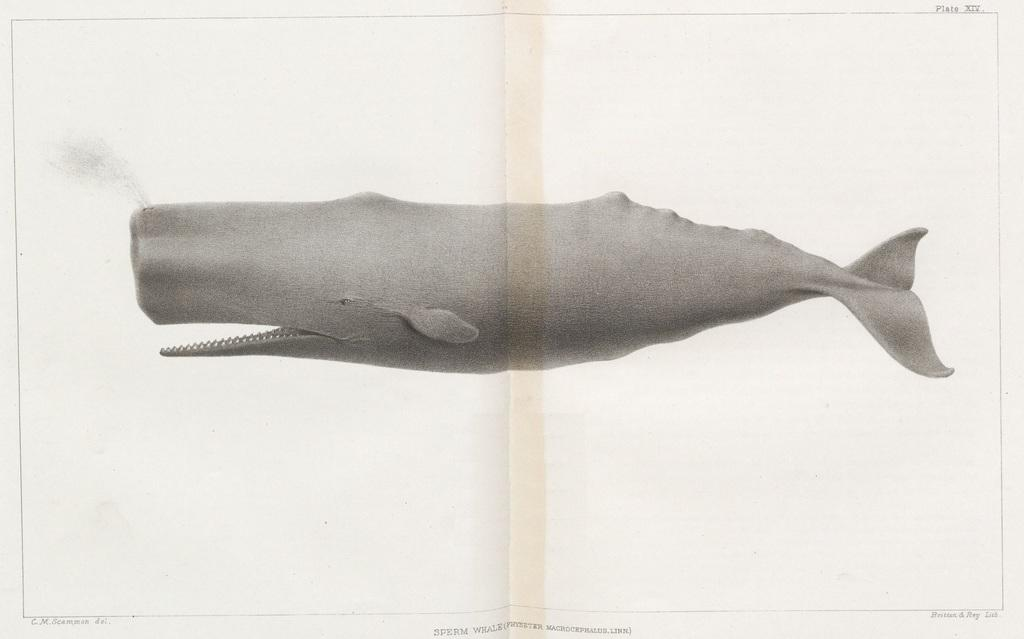What is the color scheme of the image? The image is black and white. What is the main subject of the image? There is a picture of a fish in the image. Is the picture of the fish on a specific material? The picture of the fish might be placed on paper. What type of plant is growing in the image? There is no plant present in the image; it features a picture of a fish. How does the image provide credit to the artist? The image does not provide credit to an artist, as it only shows a black and white picture of a fish. 